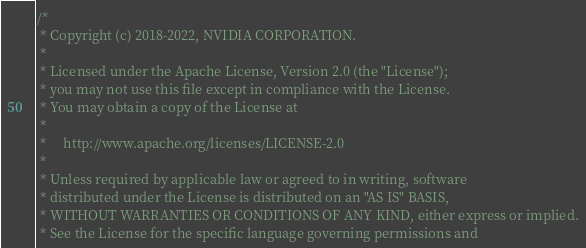Convert code to text. <code><loc_0><loc_0><loc_500><loc_500><_Cuda_>/*
 * Copyright (c) 2018-2022, NVIDIA CORPORATION.
 *
 * Licensed under the Apache License, Version 2.0 (the "License");
 * you may not use this file except in compliance with the License.
 * You may obtain a copy of the License at
 *
 *     http://www.apache.org/licenses/LICENSE-2.0
 *
 * Unless required by applicable law or agreed to in writing, software
 * distributed under the License is distributed on an "AS IS" BASIS,
 * WITHOUT WARRANTIES OR CONDITIONS OF ANY KIND, either express or implied.
 * See the License for the specific language governing permissions and</code> 